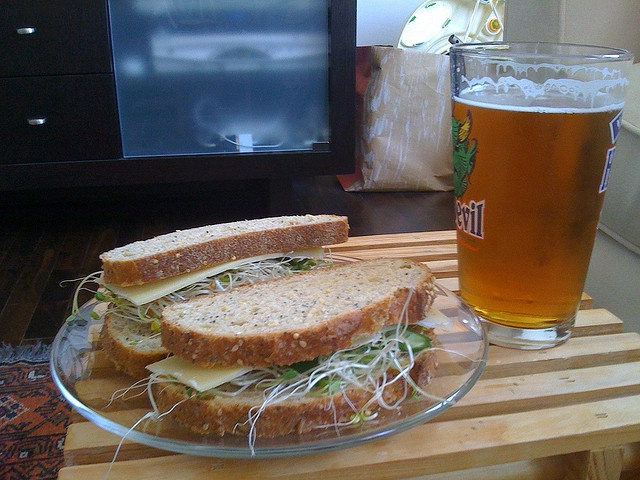Describe the objects in this image and their specific colors. I can see dining table in black, maroon, darkgray, and gray tones, tv in black, blue, navy, and gray tones, cup in black, maroon, darkgray, and brown tones, sandwich in black, darkgray, maroon, and gray tones, and sandwich in black, maroon, darkgray, and gray tones in this image. 